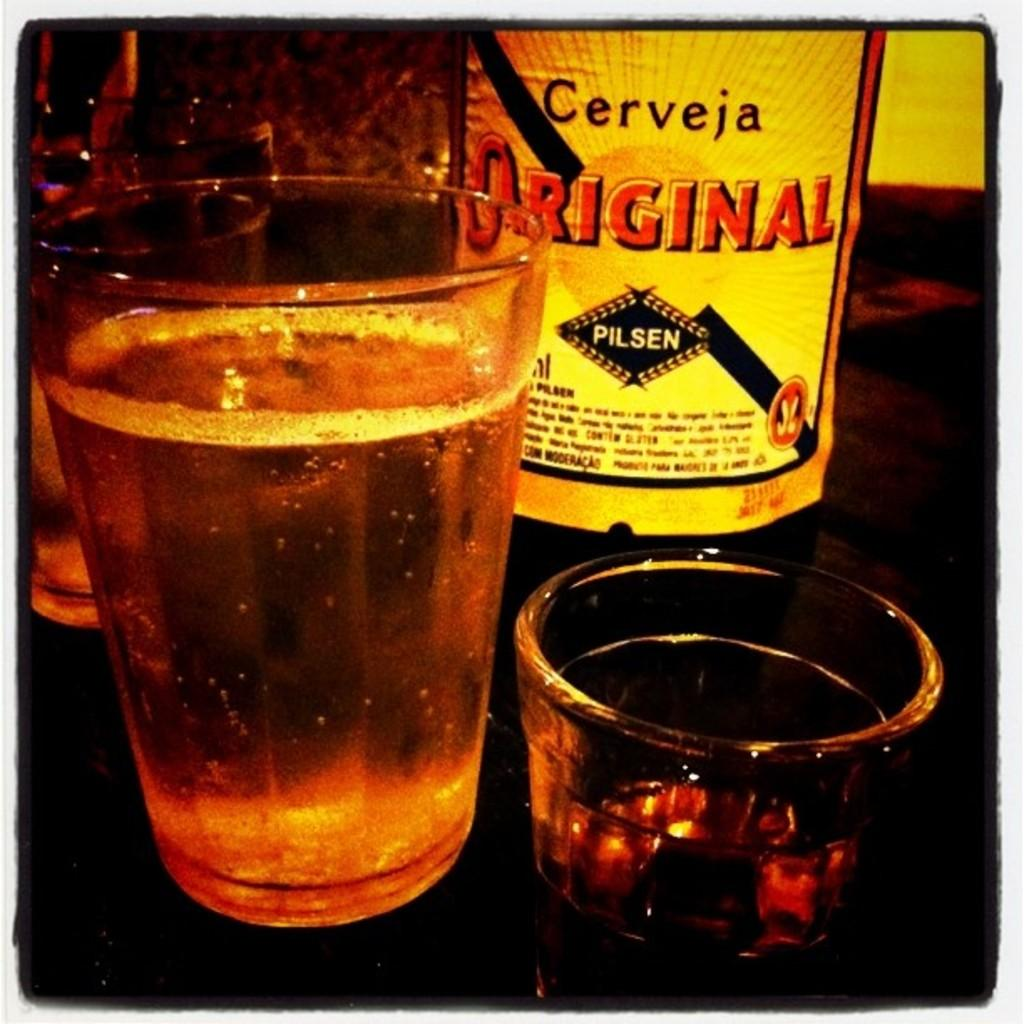<image>
Create a compact narrative representing the image presented. A bottle of alcohol next to a glass that says Cerveja on the label. 